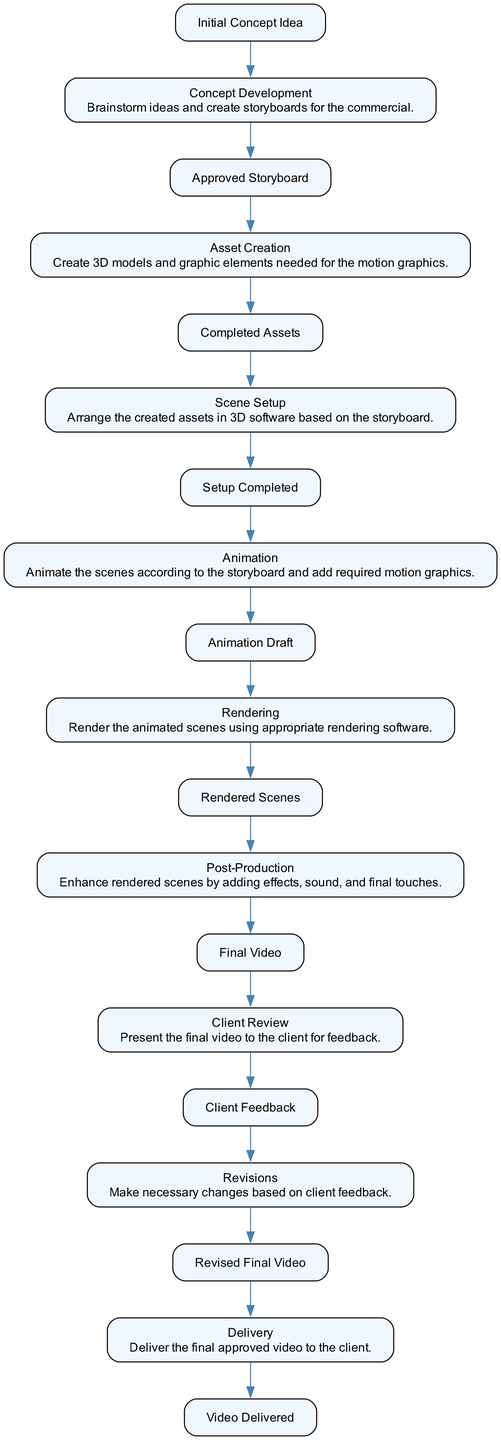What is the first activity in the diagram? The first activity listed in the diagram is "Concept Development". This is determined by following the starting point of the flow, which indicates the beginning of the process.
Answer: Concept Development How many total activities are present in the diagram? By counting each of the activities listed in the data, there are 9 activities total. Each one represents a step in the design process for the motion graphics commercial.
Answer: 9 What is the final activity before delivery? The activity immediately preceding "Delivery" is "Revised Final Video". To find this, I traced backward from "Delivery" to identify the last step in the flow.
Answer: Revised Final Video Which activity follows "Rendering"? The activity that directly follows "Rendering" is "Post-Production". This can be seen by checking the sequence of activities and their respective start and end connections.
Answer: Post-Production What is the endpoint of the "Animation" activity? The endpoint for the "Animation" activity is "Animation Draft". This is identified by looking at the end node linked to "Animation", as described in the activity's details.
Answer: Animation Draft How many edges are connected to the "Client Review" activity? "Client Review" has 2 edges connected to it, one leading into it from "Final Video" and another leading out to "Client Feedback". This is determined by analyzing the connections of the nodes in the flow.
Answer: 2 What is the primary purpose of the "Post-Production" activity? The purpose of "Post-Production" is to enhance the rendered scenes. This detail is specified in the description of the activity, emphasizing its role in the overall process.
Answer: Enhance rendered scenes Which activity directly leads to "Client Feedback"? The activity that directly leads to "Client Feedback" is "Client Review". By following the flow from the preceding activity, this connection can be clearly seen.
Answer: Client Review What is the last outcome of the process depicted in the diagram? The final outcome is "Video Delivered". This can be determined by looking at the final end node in the activity flow, completing the motion graphics commercial workflow.
Answer: Video Delivered 